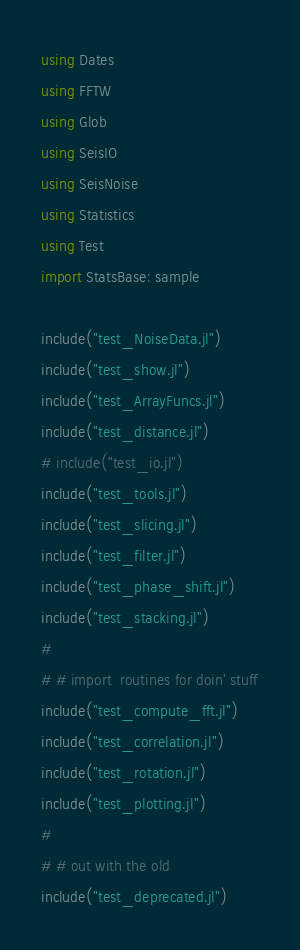<code> <loc_0><loc_0><loc_500><loc_500><_Julia_>using Dates 
using FFTW
using Glob
using SeisIO
using SeisNoise
using Statistics
using Test
import StatsBase: sample

include("test_NoiseData.jl")
include("test_show.jl")
include("test_ArrayFuncs.jl")
include("test_distance.jl")
# include("test_io.jl")
include("test_tools.jl")
include("test_slicing.jl")
include("test_filter.jl")
include("test_phase_shift.jl")
include("test_stacking.jl")
#
# # import  routines for doin' stuff
include("test_compute_fft.jl")
include("test_correlation.jl")
include("test_rotation.jl")
include("test_plotting.jl")
#
# # out with the old
include("test_deprecated.jl")
</code> 